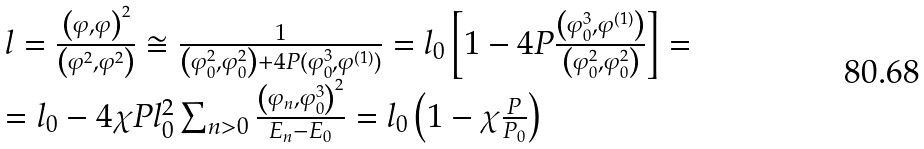Convert formula to latex. <formula><loc_0><loc_0><loc_500><loc_500>\begin{array} { l } l = \frac { \left ( \varphi , \varphi \right ) ^ { 2 } } { \left ( \varphi ^ { 2 } , \varphi ^ { 2 } \right ) } \cong \frac { 1 } { \left ( \varphi _ { 0 } ^ { 2 } , \varphi _ { 0 } ^ { 2 } \right ) + 4 P ( \varphi _ { 0 } ^ { 3 } , \varphi ^ { ( 1 ) } ) } = l _ { 0 } \left [ 1 - 4 P \frac { \left ( \varphi _ { 0 } ^ { 3 } , \varphi ^ { ( 1 ) } \right ) } { \left ( \varphi _ { 0 } ^ { 2 } , \varphi _ { 0 } ^ { 2 } \right ) } \right ] = \\ = l _ { 0 } - 4 \chi P l _ { 0 } ^ { 2 } \sum _ { n > 0 } \frac { \left ( \varphi _ { n } , \varphi _ { 0 } ^ { 3 } \right ) ^ { 2 } } { E _ { n } - E _ { 0 } } = l _ { 0 } \left ( 1 - \chi \frac { P } { P _ { 0 } } \right ) \end{array}</formula> 